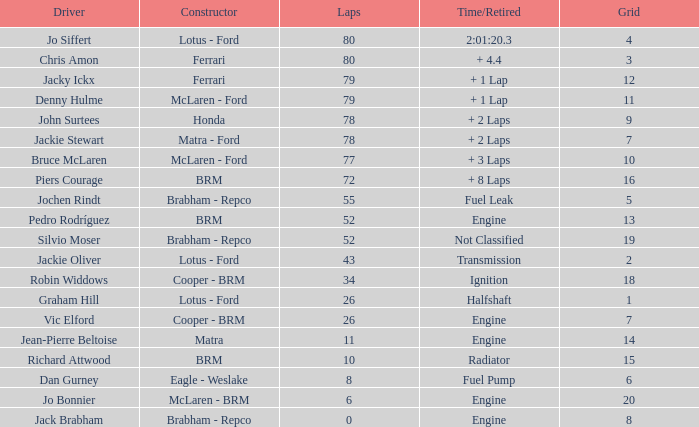Help me parse the entirety of this table. {'header': ['Driver', 'Constructor', 'Laps', 'Time/Retired', 'Grid'], 'rows': [['Jo Siffert', 'Lotus - Ford', '80', '2:01:20.3', '4'], ['Chris Amon', 'Ferrari', '80', '+ 4.4', '3'], ['Jacky Ickx', 'Ferrari', '79', '+ 1 Lap', '12'], ['Denny Hulme', 'McLaren - Ford', '79', '+ 1 Lap', '11'], ['John Surtees', 'Honda', '78', '+ 2 Laps', '9'], ['Jackie Stewart', 'Matra - Ford', '78', '+ 2 Laps', '7'], ['Bruce McLaren', 'McLaren - Ford', '77', '+ 3 Laps', '10'], ['Piers Courage', 'BRM', '72', '+ 8 Laps', '16'], ['Jochen Rindt', 'Brabham - Repco', '55', 'Fuel Leak', '5'], ['Pedro Rodríguez', 'BRM', '52', 'Engine', '13'], ['Silvio Moser', 'Brabham - Repco', '52', 'Not Classified', '19'], ['Jackie Oliver', 'Lotus - Ford', '43', 'Transmission', '2'], ['Robin Widdows', 'Cooper - BRM', '34', 'Ignition', '18'], ['Graham Hill', 'Lotus - Ford', '26', 'Halfshaft', '1'], ['Vic Elford', 'Cooper - BRM', '26', 'Engine', '7'], ['Jean-Pierre Beltoise', 'Matra', '11', 'Engine', '14'], ['Richard Attwood', 'BRM', '10', 'Radiator', '15'], ['Dan Gurney', 'Eagle - Weslake', '8', 'Fuel Pump', '6'], ['Jo Bonnier', 'McLaren - BRM', '6', 'Engine', '20'], ['Jack Brabham', 'Brabham - Repco', '0', 'Engine', '8']]} When the driver richard attwood has a constructor of brm, what is the number of laps? 10.0. 